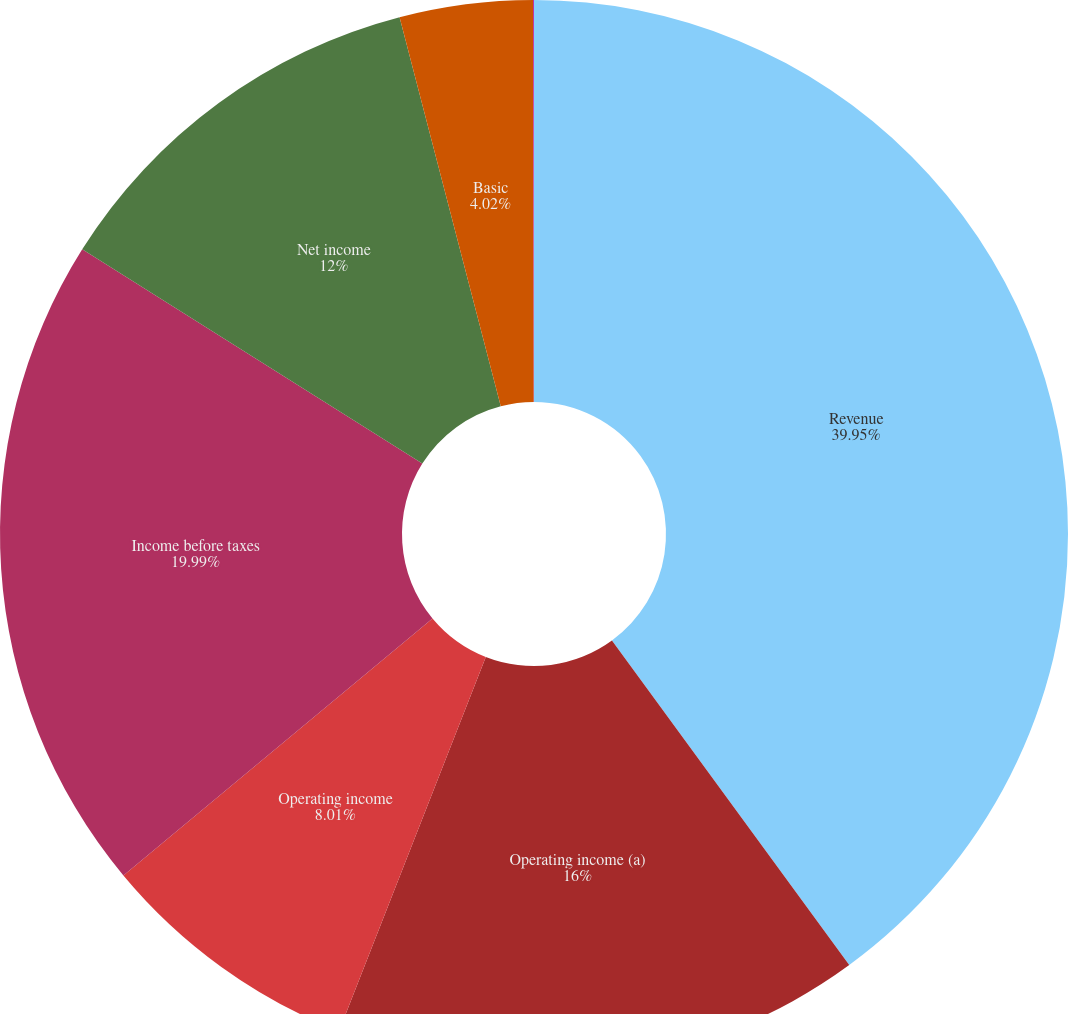Convert chart to OTSL. <chart><loc_0><loc_0><loc_500><loc_500><pie_chart><fcel>Revenue<fcel>Operating income (a)<fcel>Operating income<fcel>Income before taxes<fcel>Net income<fcel>Basic<fcel>Diluted<nl><fcel>39.95%<fcel>16.0%<fcel>8.01%<fcel>19.99%<fcel>12.0%<fcel>4.02%<fcel>0.03%<nl></chart> 